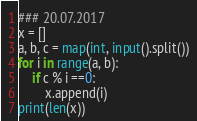<code> <loc_0><loc_0><loc_500><loc_500><_Python_>### 20.07.2017
x = []
a, b, c = map(int, input().split())
for i in range(a, b):
	if c % i ==0:
		x.append(i)
print(len(x))</code> 